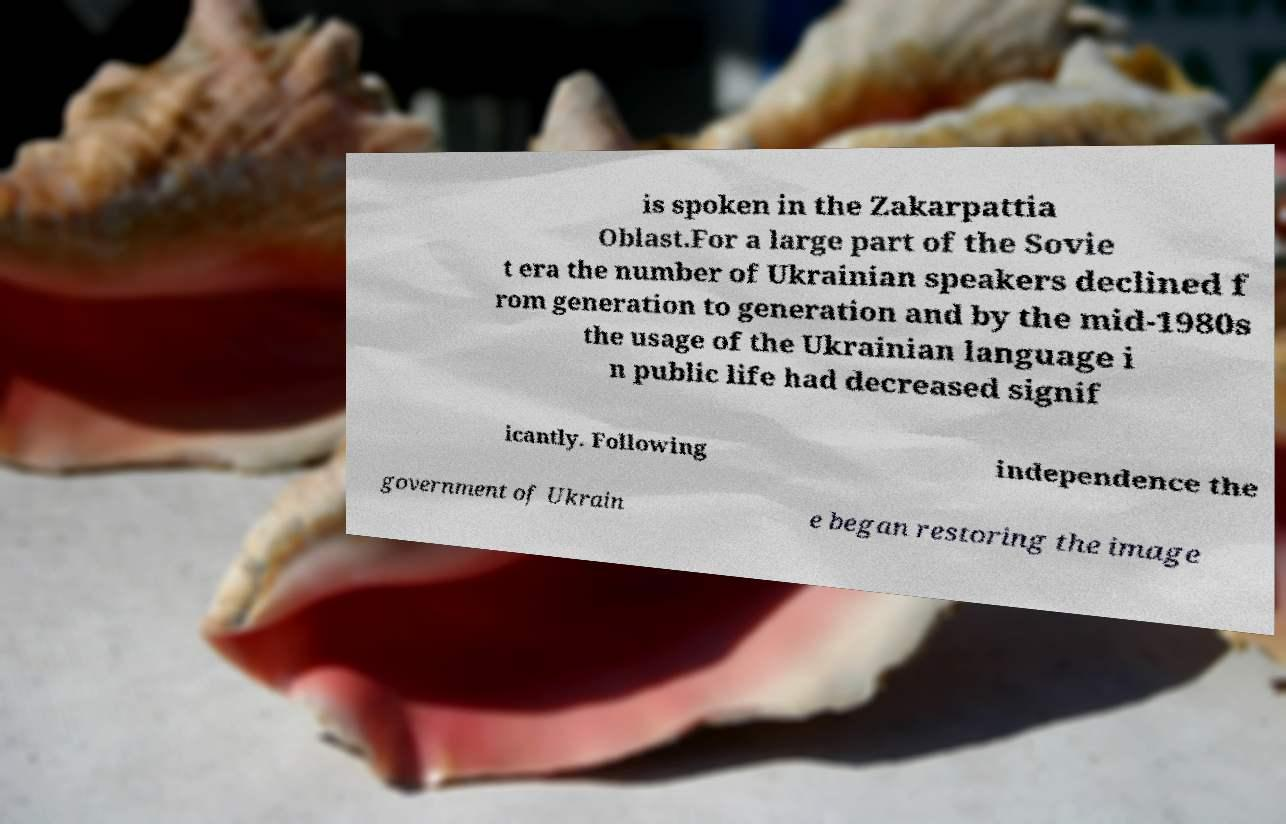Can you read and provide the text displayed in the image?This photo seems to have some interesting text. Can you extract and type it out for me? is spoken in the Zakarpattia Oblast.For a large part of the Sovie t era the number of Ukrainian speakers declined f rom generation to generation and by the mid-1980s the usage of the Ukrainian language i n public life had decreased signif icantly. Following independence the government of Ukrain e began restoring the image 